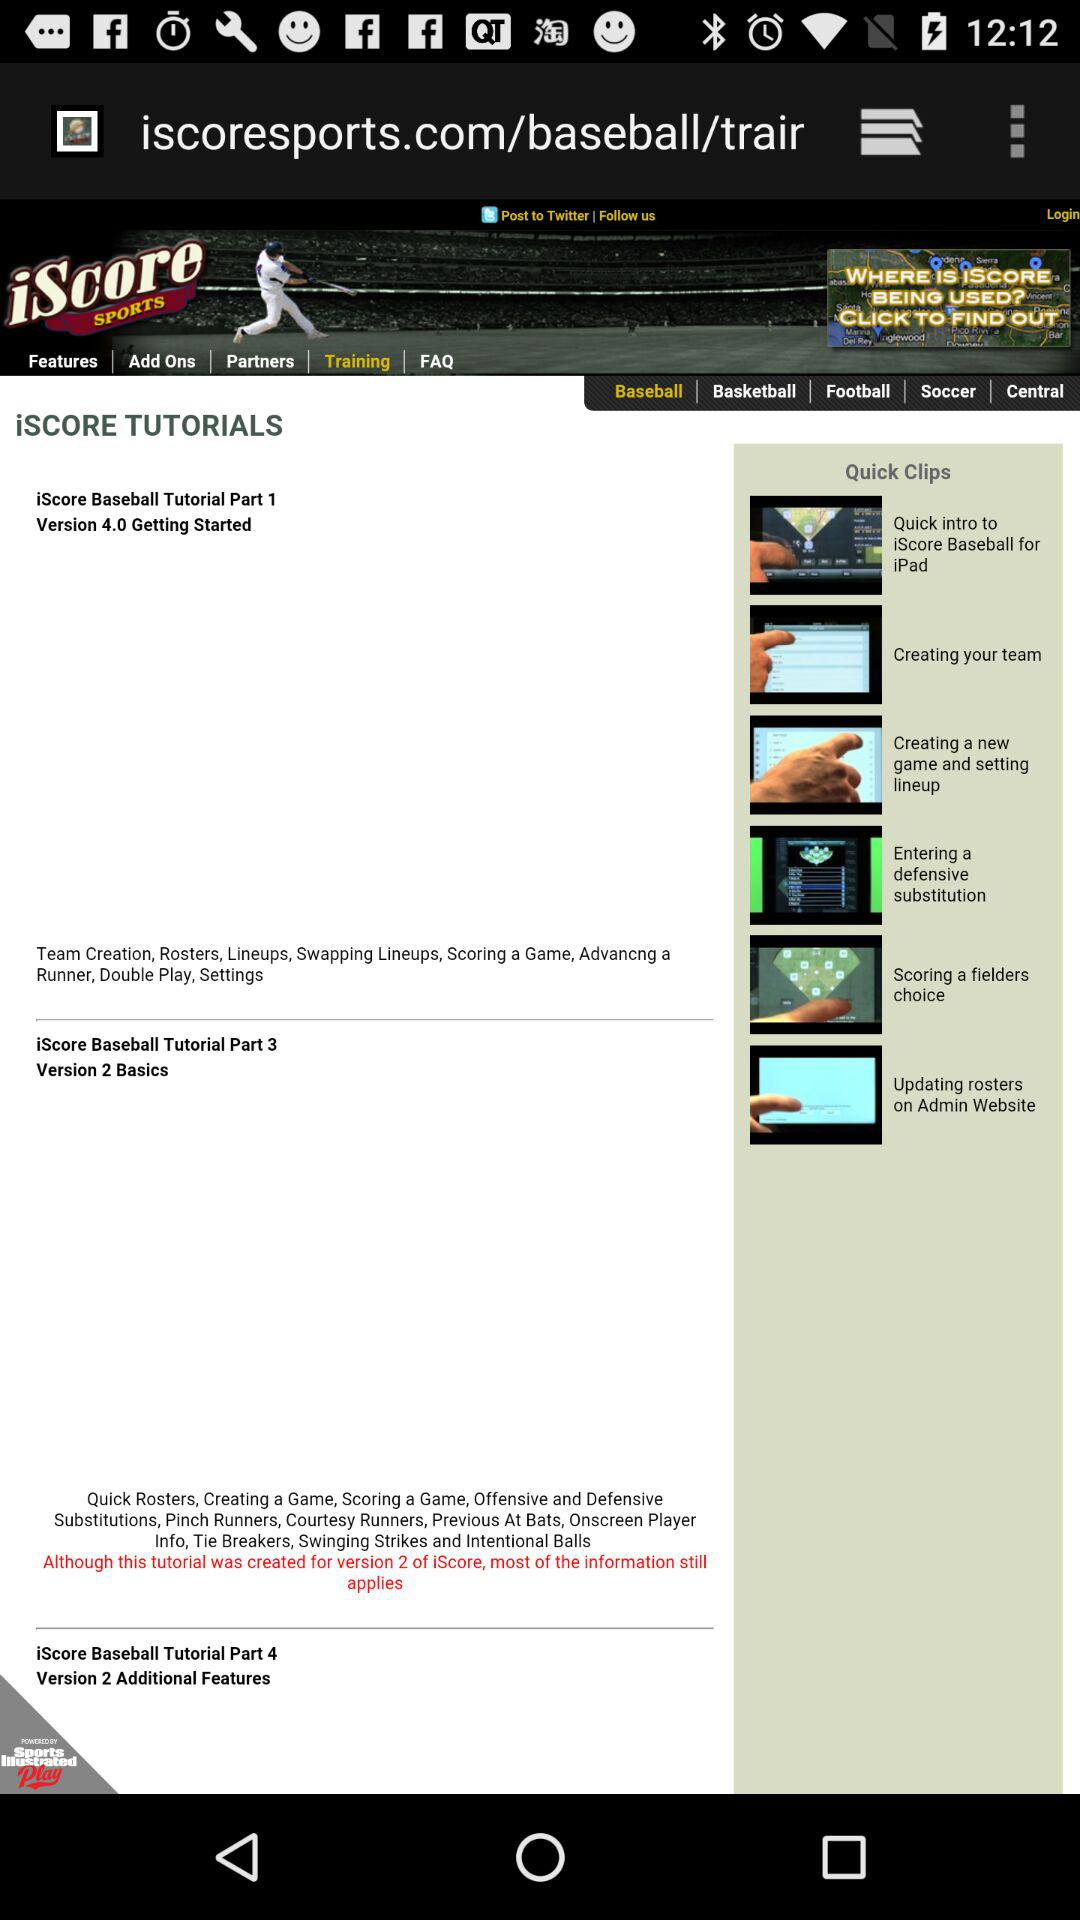What's the selected game tab? The selected game tab is "Baseball". 